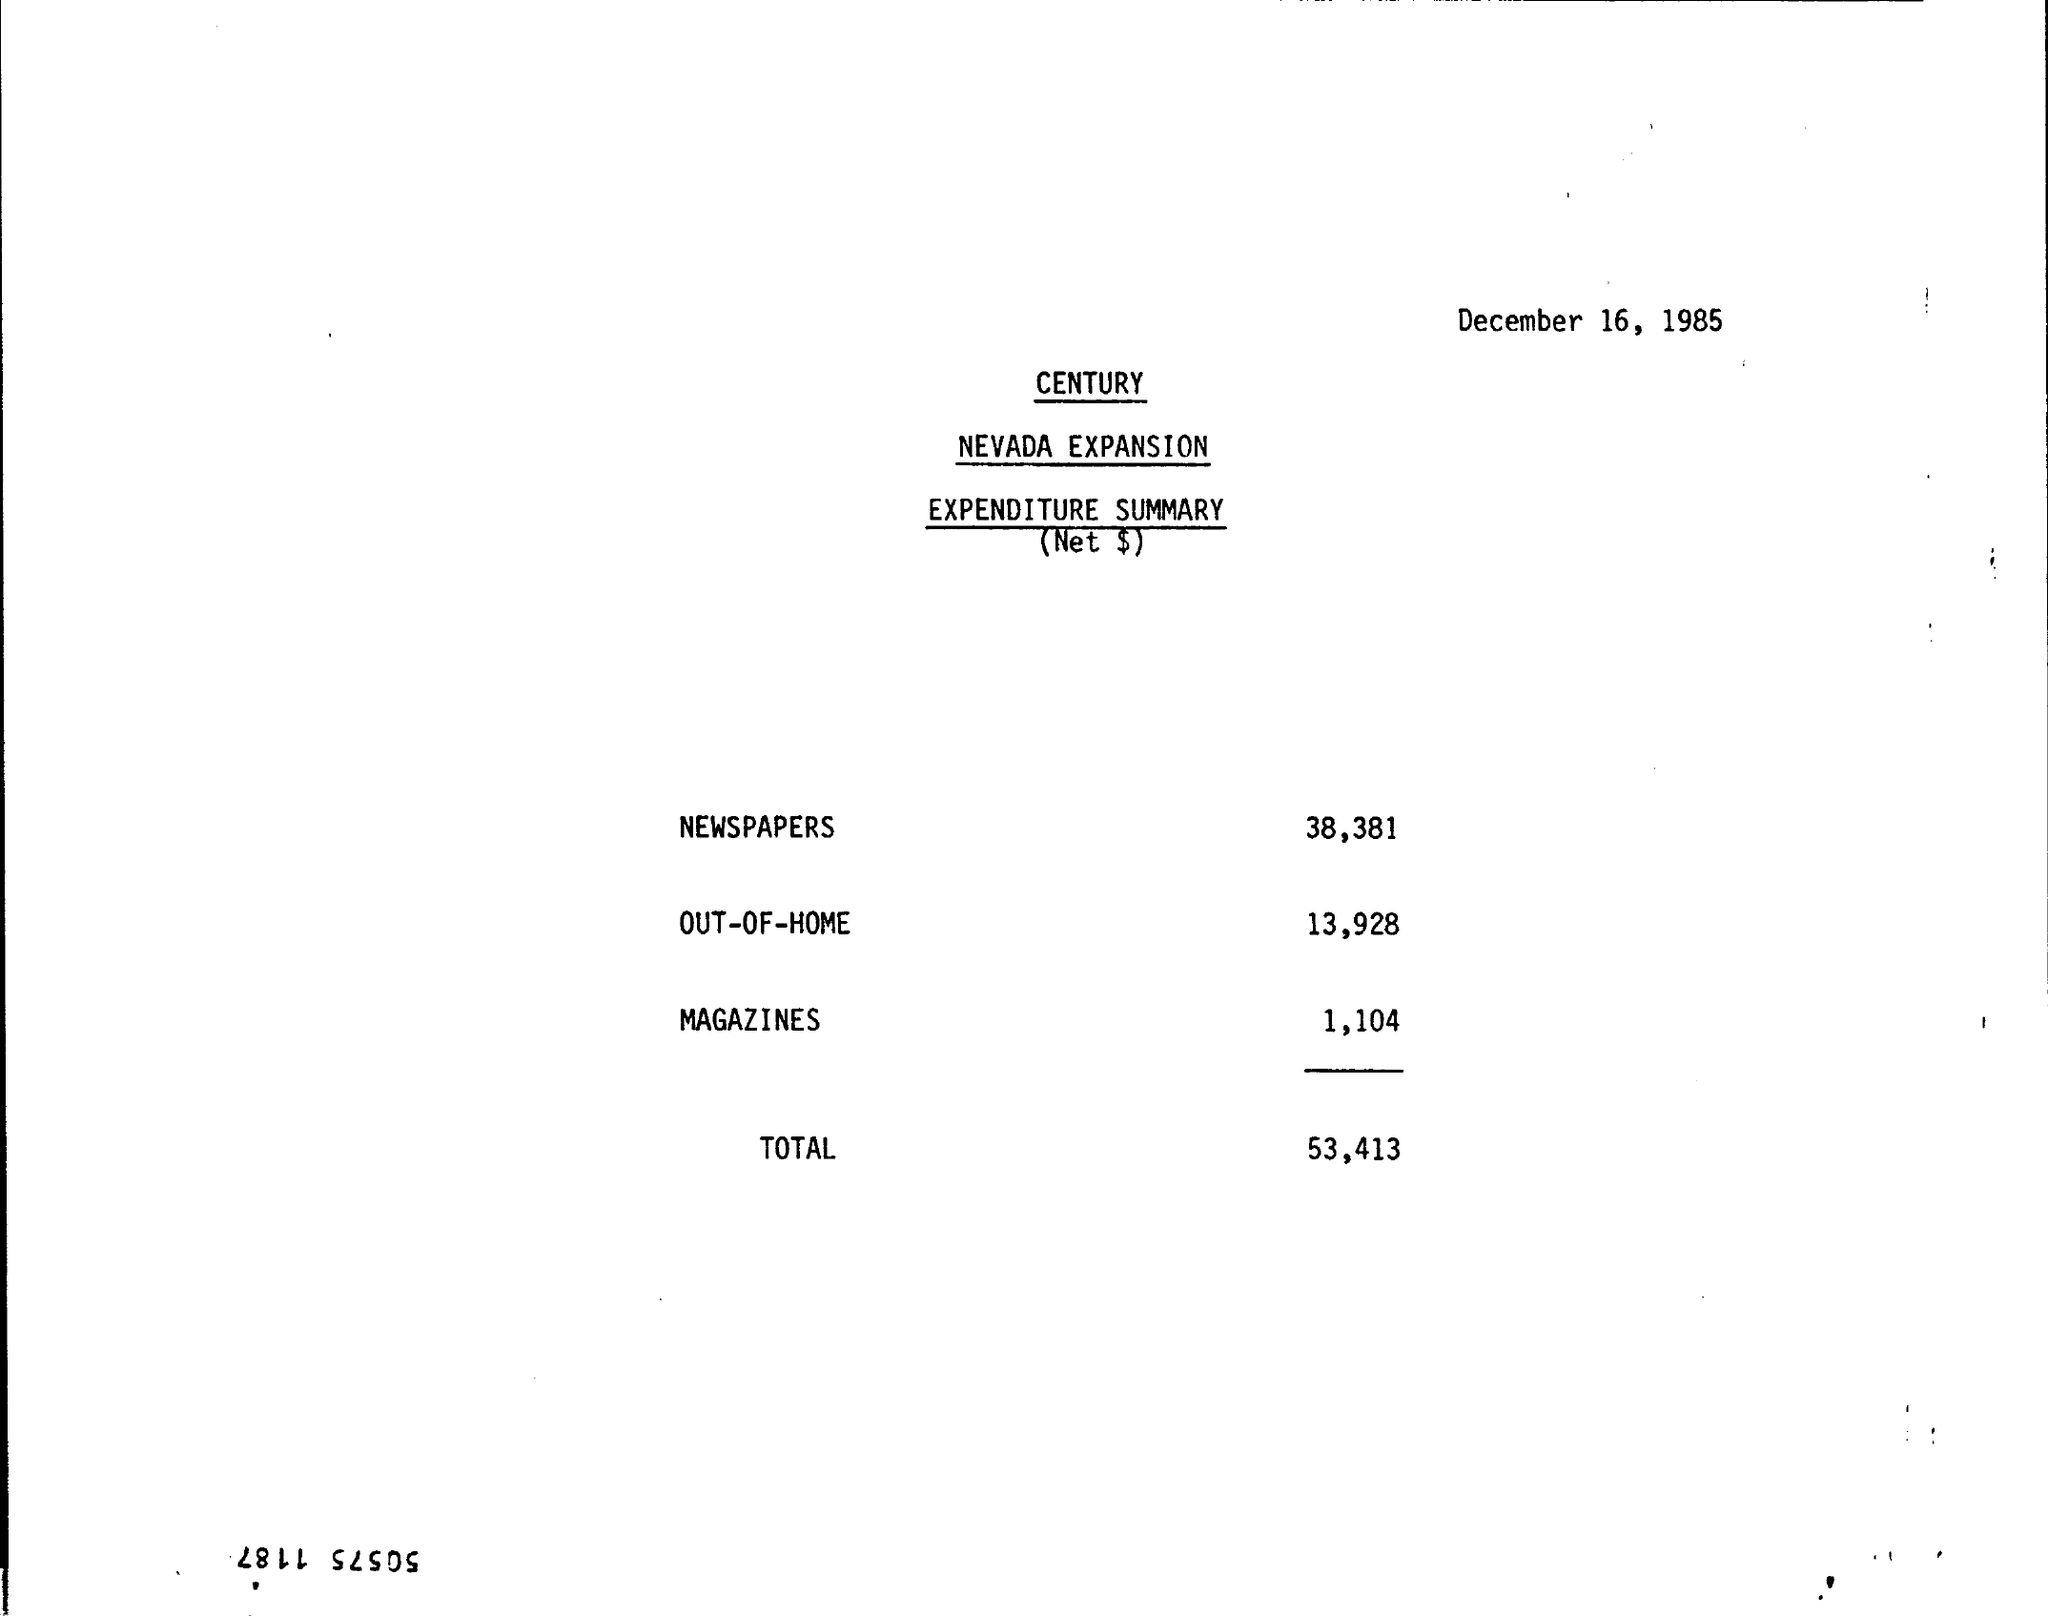What can you tell about the expense for out-of-home media? The expense for out-of-home media in the document is stated as $13,928. 